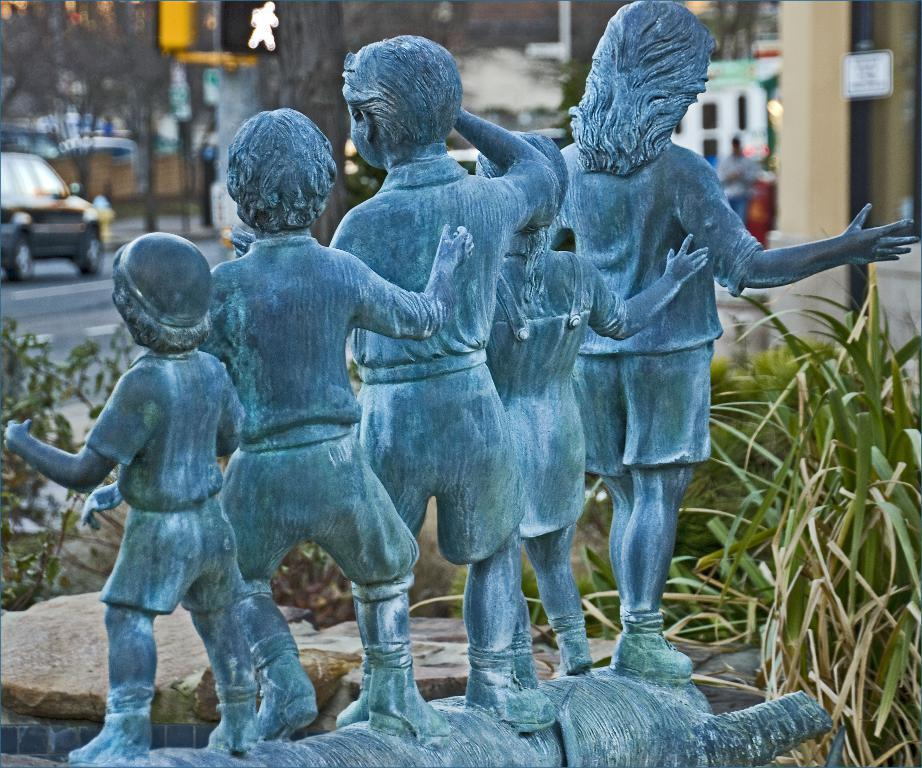What is the main subject in the image? There is a statue in the image. What other elements can be seen around the statue? There are stones and plants in the image. What can be seen in the background of the image? There is a person, trees, a car on the road, and some unspecified objects in the background of the image. How would you describe the overall quality of the image? The image is blurry. How many children are playing with the statue's fang in the image? There are no children or fangs present in the image. 